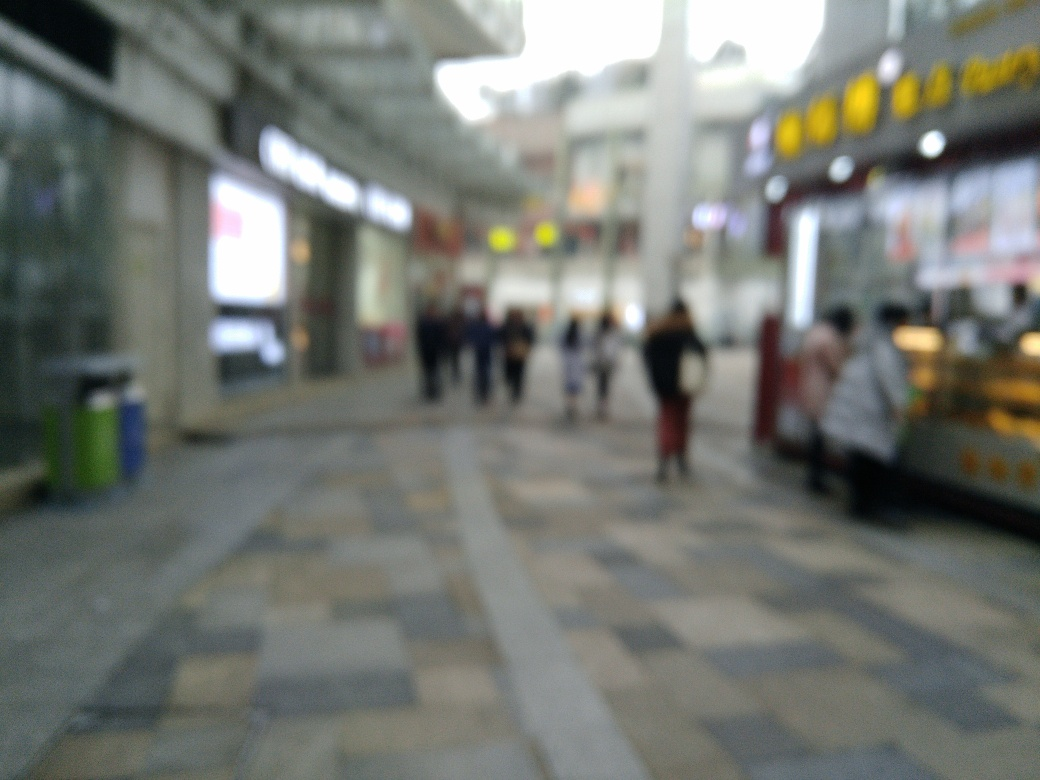Can you tell what kind of location this is? It appears to be an outdoor shopping area or pedestrian zone, with shops on either side and people walking, although the specific details are not clear because of the blur. 